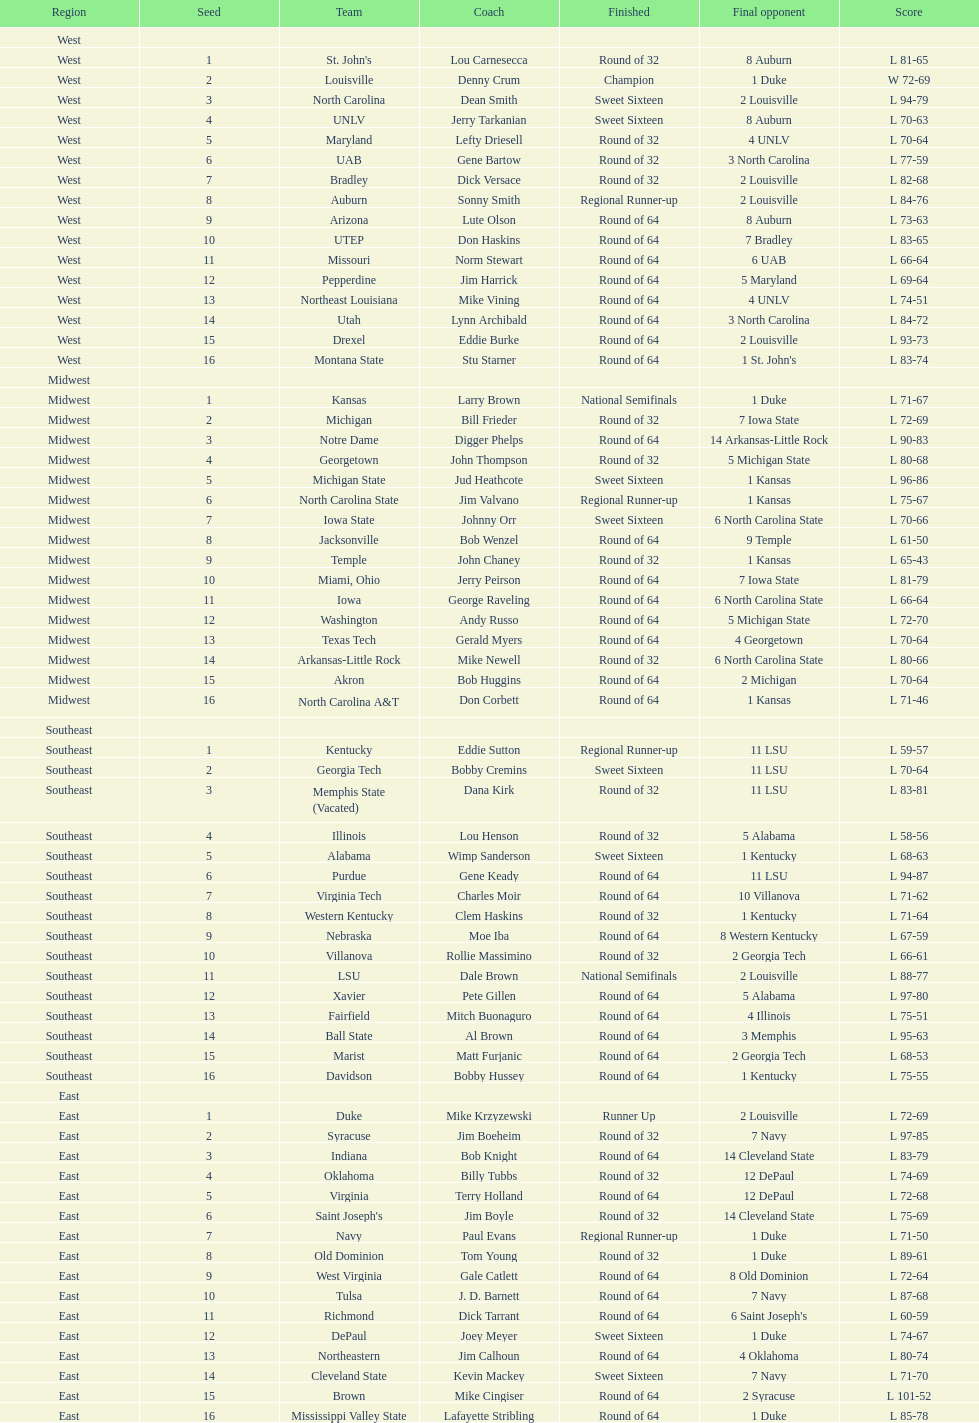Parse the full table. {'header': ['Region', 'Seed', 'Team', 'Coach', 'Finished', 'Final opponent', 'Score'], 'rows': [['West', '', '', '', '', '', ''], ['West', '1', "St. John's", 'Lou Carnesecca', 'Round of 32', '8 Auburn', 'L 81-65'], ['West', '2', 'Louisville', 'Denny Crum', 'Champion', '1 Duke', 'W 72-69'], ['West', '3', 'North Carolina', 'Dean Smith', 'Sweet Sixteen', '2 Louisville', 'L 94-79'], ['West', '4', 'UNLV', 'Jerry Tarkanian', 'Sweet Sixteen', '8 Auburn', 'L 70-63'], ['West', '5', 'Maryland', 'Lefty Driesell', 'Round of 32', '4 UNLV', 'L 70-64'], ['West', '6', 'UAB', 'Gene Bartow', 'Round of 32', '3 North Carolina', 'L 77-59'], ['West', '7', 'Bradley', 'Dick Versace', 'Round of 32', '2 Louisville', 'L 82-68'], ['West', '8', 'Auburn', 'Sonny Smith', 'Regional Runner-up', '2 Louisville', 'L 84-76'], ['West', '9', 'Arizona', 'Lute Olson', 'Round of 64', '8 Auburn', 'L 73-63'], ['West', '10', 'UTEP', 'Don Haskins', 'Round of 64', '7 Bradley', 'L 83-65'], ['West', '11', 'Missouri', 'Norm Stewart', 'Round of 64', '6 UAB', 'L 66-64'], ['West', '12', 'Pepperdine', 'Jim Harrick', 'Round of 64', '5 Maryland', 'L 69-64'], ['West', '13', 'Northeast Louisiana', 'Mike Vining', 'Round of 64', '4 UNLV', 'L 74-51'], ['West', '14', 'Utah', 'Lynn Archibald', 'Round of 64', '3 North Carolina', 'L 84-72'], ['West', '15', 'Drexel', 'Eddie Burke', 'Round of 64', '2 Louisville', 'L 93-73'], ['West', '16', 'Montana State', 'Stu Starner', 'Round of 64', "1 St. John's", 'L 83-74'], ['Midwest', '', '', '', '', '', ''], ['Midwest', '1', 'Kansas', 'Larry Brown', 'National Semifinals', '1 Duke', 'L 71-67'], ['Midwest', '2', 'Michigan', 'Bill Frieder', 'Round of 32', '7 Iowa State', 'L 72-69'], ['Midwest', '3', 'Notre Dame', 'Digger Phelps', 'Round of 64', '14 Arkansas-Little Rock', 'L 90-83'], ['Midwest', '4', 'Georgetown', 'John Thompson', 'Round of 32', '5 Michigan State', 'L 80-68'], ['Midwest', '5', 'Michigan State', 'Jud Heathcote', 'Sweet Sixteen', '1 Kansas', 'L 96-86'], ['Midwest', '6', 'North Carolina State', 'Jim Valvano', 'Regional Runner-up', '1 Kansas', 'L 75-67'], ['Midwest', '7', 'Iowa State', 'Johnny Orr', 'Sweet Sixteen', '6 North Carolina State', 'L 70-66'], ['Midwest', '8', 'Jacksonville', 'Bob Wenzel', 'Round of 64', '9 Temple', 'L 61-50'], ['Midwest', '9', 'Temple', 'John Chaney', 'Round of 32', '1 Kansas', 'L 65-43'], ['Midwest', '10', 'Miami, Ohio', 'Jerry Peirson', 'Round of 64', '7 Iowa State', 'L 81-79'], ['Midwest', '11', 'Iowa', 'George Raveling', 'Round of 64', '6 North Carolina State', 'L 66-64'], ['Midwest', '12', 'Washington', 'Andy Russo', 'Round of 64', '5 Michigan State', 'L 72-70'], ['Midwest', '13', 'Texas Tech', 'Gerald Myers', 'Round of 64', '4 Georgetown', 'L 70-64'], ['Midwest', '14', 'Arkansas-Little Rock', 'Mike Newell', 'Round of 32', '6 North Carolina State', 'L 80-66'], ['Midwest', '15', 'Akron', 'Bob Huggins', 'Round of 64', '2 Michigan', 'L 70-64'], ['Midwest', '16', 'North Carolina A&T', 'Don Corbett', 'Round of 64', '1 Kansas', 'L 71-46'], ['Southeast', '', '', '', '', '', ''], ['Southeast', '1', 'Kentucky', 'Eddie Sutton', 'Regional Runner-up', '11 LSU', 'L 59-57'], ['Southeast', '2', 'Georgia Tech', 'Bobby Cremins', 'Sweet Sixteen', '11 LSU', 'L 70-64'], ['Southeast', '3', 'Memphis State (Vacated)', 'Dana Kirk', 'Round of 32', '11 LSU', 'L 83-81'], ['Southeast', '4', 'Illinois', 'Lou Henson', 'Round of 32', '5 Alabama', 'L 58-56'], ['Southeast', '5', 'Alabama', 'Wimp Sanderson', 'Sweet Sixteen', '1 Kentucky', 'L 68-63'], ['Southeast', '6', 'Purdue', 'Gene Keady', 'Round of 64', '11 LSU', 'L 94-87'], ['Southeast', '7', 'Virginia Tech', 'Charles Moir', 'Round of 64', '10 Villanova', 'L 71-62'], ['Southeast', '8', 'Western Kentucky', 'Clem Haskins', 'Round of 32', '1 Kentucky', 'L 71-64'], ['Southeast', '9', 'Nebraska', 'Moe Iba', 'Round of 64', '8 Western Kentucky', 'L 67-59'], ['Southeast', '10', 'Villanova', 'Rollie Massimino', 'Round of 32', '2 Georgia Tech', 'L 66-61'], ['Southeast', '11', 'LSU', 'Dale Brown', 'National Semifinals', '2 Louisville', 'L 88-77'], ['Southeast', '12', 'Xavier', 'Pete Gillen', 'Round of 64', '5 Alabama', 'L 97-80'], ['Southeast', '13', 'Fairfield', 'Mitch Buonaguro', 'Round of 64', '4 Illinois', 'L 75-51'], ['Southeast', '14', 'Ball State', 'Al Brown', 'Round of 64', '3 Memphis', 'L 95-63'], ['Southeast', '15', 'Marist', 'Matt Furjanic', 'Round of 64', '2 Georgia Tech', 'L 68-53'], ['Southeast', '16', 'Davidson', 'Bobby Hussey', 'Round of 64', '1 Kentucky', 'L 75-55'], ['East', '', '', '', '', '', ''], ['East', '1', 'Duke', 'Mike Krzyzewski', 'Runner Up', '2 Louisville', 'L 72-69'], ['East', '2', 'Syracuse', 'Jim Boeheim', 'Round of 32', '7 Navy', 'L 97-85'], ['East', '3', 'Indiana', 'Bob Knight', 'Round of 64', '14 Cleveland State', 'L 83-79'], ['East', '4', 'Oklahoma', 'Billy Tubbs', 'Round of 32', '12 DePaul', 'L 74-69'], ['East', '5', 'Virginia', 'Terry Holland', 'Round of 64', '12 DePaul', 'L 72-68'], ['East', '6', "Saint Joseph's", 'Jim Boyle', 'Round of 32', '14 Cleveland State', 'L 75-69'], ['East', '7', 'Navy', 'Paul Evans', 'Regional Runner-up', '1 Duke', 'L 71-50'], ['East', '8', 'Old Dominion', 'Tom Young', 'Round of 32', '1 Duke', 'L 89-61'], ['East', '9', 'West Virginia', 'Gale Catlett', 'Round of 64', '8 Old Dominion', 'L 72-64'], ['East', '10', 'Tulsa', 'J. D. Barnett', 'Round of 64', '7 Navy', 'L 87-68'], ['East', '11', 'Richmond', 'Dick Tarrant', 'Round of 64', "6 Saint Joseph's", 'L 60-59'], ['East', '12', 'DePaul', 'Joey Meyer', 'Sweet Sixteen', '1 Duke', 'L 74-67'], ['East', '13', 'Northeastern', 'Jim Calhoun', 'Round of 64', '4 Oklahoma', 'L 80-74'], ['East', '14', 'Cleveland State', 'Kevin Mackey', 'Sweet Sixteen', '7 Navy', 'L 71-70'], ['East', '15', 'Brown', 'Mike Cingiser', 'Round of 64', '2 Syracuse', 'L 101-52'], ['East', '16', 'Mississippi Valley State', 'Lafayette Stribling', 'Round of 64', '1 Duke', 'L 85-78']]} How many teams were involved in the play? 64. 